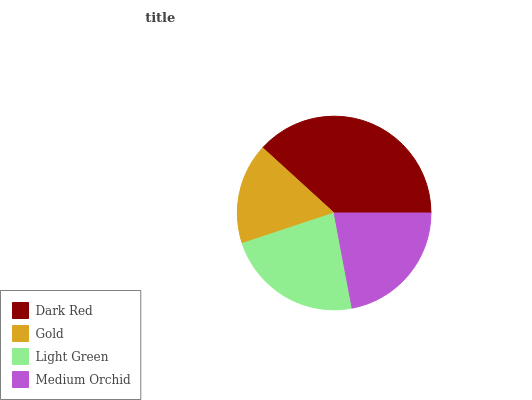Is Gold the minimum?
Answer yes or no. Yes. Is Dark Red the maximum?
Answer yes or no. Yes. Is Light Green the minimum?
Answer yes or no. No. Is Light Green the maximum?
Answer yes or no. No. Is Light Green greater than Gold?
Answer yes or no. Yes. Is Gold less than Light Green?
Answer yes or no. Yes. Is Gold greater than Light Green?
Answer yes or no. No. Is Light Green less than Gold?
Answer yes or no. No. Is Light Green the high median?
Answer yes or no. Yes. Is Medium Orchid the low median?
Answer yes or no. Yes. Is Medium Orchid the high median?
Answer yes or no. No. Is Dark Red the low median?
Answer yes or no. No. 